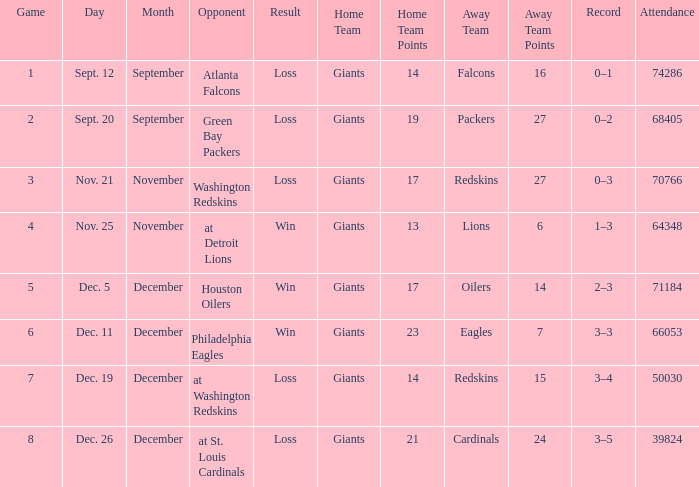What is the minimum number of opponents? 6.0. 